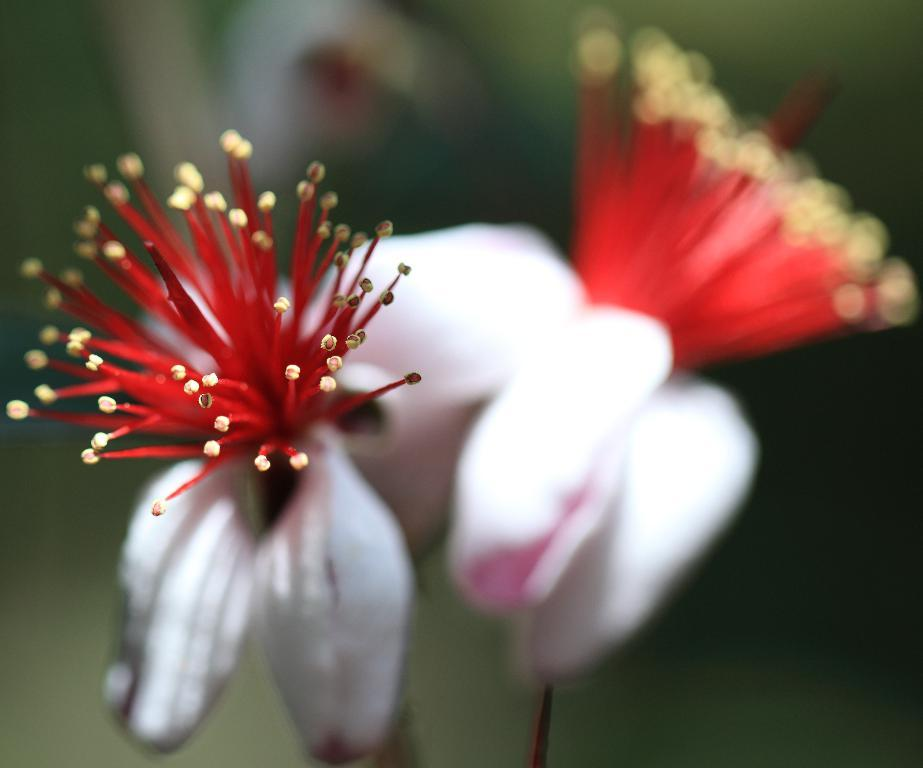What is the main subject of the image? There is a flower in the image. Can you describe the colors of the flower? The flower has white and red colors. How would you describe the background of the image? The background of the image is blurry. How many coaches can be seen in the image? There are no coaches present in the image; it features a flower with white and red colors against a blurry background. What type of knot is used to tie the stem of the flower in the image? There is no knot visible in the image, as it focuses on the flower itself and not its stem. 